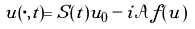<formula> <loc_0><loc_0><loc_500><loc_500>u ( \cdot , t ) = S ( t ) u _ { 0 } - i \mathcal { A } f ( u )</formula> 